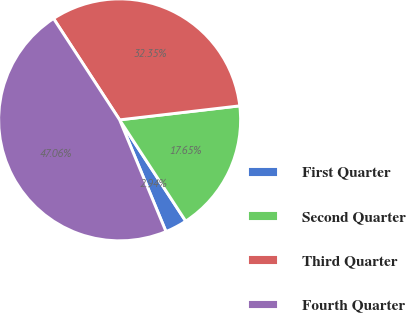Convert chart to OTSL. <chart><loc_0><loc_0><loc_500><loc_500><pie_chart><fcel>First Quarter<fcel>Second Quarter<fcel>Third Quarter<fcel>Fourth Quarter<nl><fcel>2.94%<fcel>17.65%<fcel>32.35%<fcel>47.06%<nl></chart> 